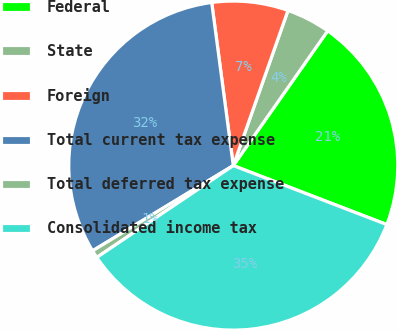<chart> <loc_0><loc_0><loc_500><loc_500><pie_chart><fcel>Federal<fcel>State<fcel>Foreign<fcel>Total current tax expense<fcel>Total deferred tax expense<fcel>Consolidated income tax<nl><fcel>21.11%<fcel>4.33%<fcel>7.49%<fcel>31.57%<fcel>0.76%<fcel>34.73%<nl></chart> 